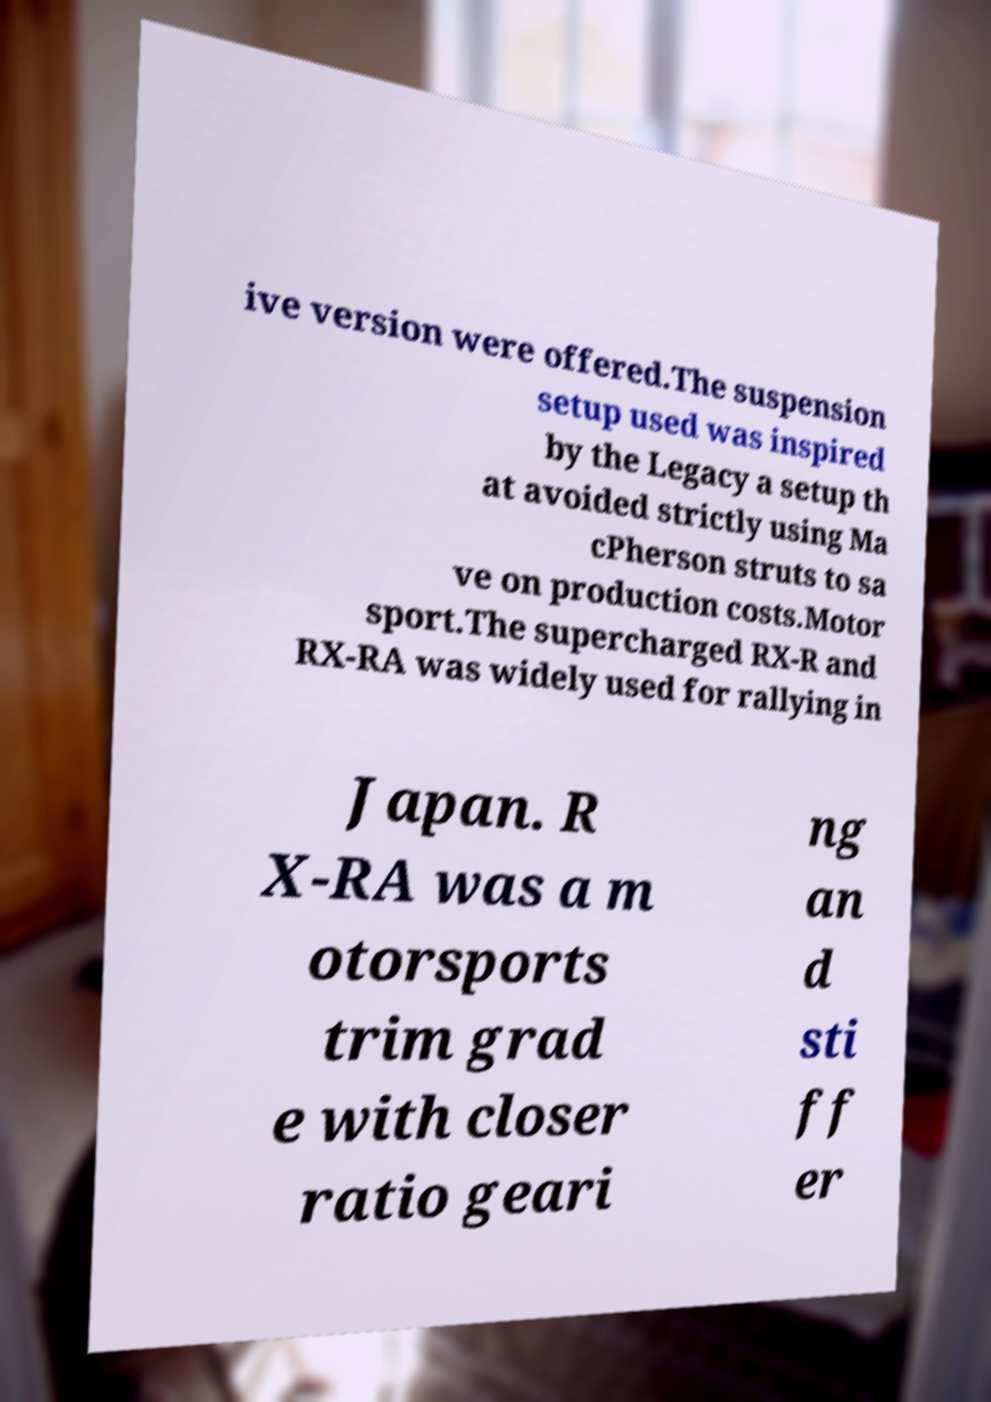Please identify and transcribe the text found in this image. ive version were offered.The suspension setup used was inspired by the Legacy a setup th at avoided strictly using Ma cPherson struts to sa ve on production costs.Motor sport.The supercharged RX-R and RX-RA was widely used for rallying in Japan. R X-RA was a m otorsports trim grad e with closer ratio geari ng an d sti ff er 